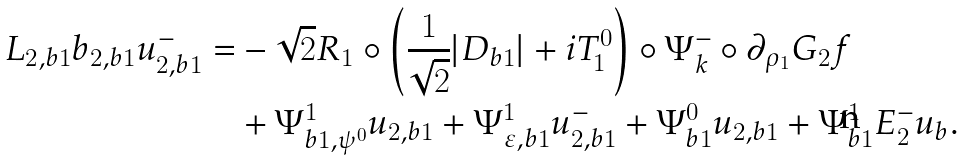Convert formula to latex. <formula><loc_0><loc_0><loc_500><loc_500>L _ { 2 , b 1 } \L b _ { 2 , b 1 } u _ { 2 , b 1 } ^ { - } = & - \sqrt { 2 } R _ { 1 } \circ \left ( \frac { 1 } { \sqrt { 2 } } | D _ { b 1 } | + i T _ { 1 } ^ { 0 } \right ) \circ \Psi ^ { - } _ { k } \circ \partial _ { \rho _ { 1 } } G _ { 2 } f \\ & + \Psi ^ { 1 } _ { b 1 , \psi ^ { 0 } } u _ { 2 , b 1 } + \Psi ^ { 1 } _ { \varepsilon , b 1 } u _ { 2 , b 1 } ^ { - } + \Psi ^ { 0 } _ { b 1 } u _ { 2 , b 1 } + \Psi ^ { 1 } _ { b 1 } E ^ { - } _ { 2 } u _ { b } .</formula> 